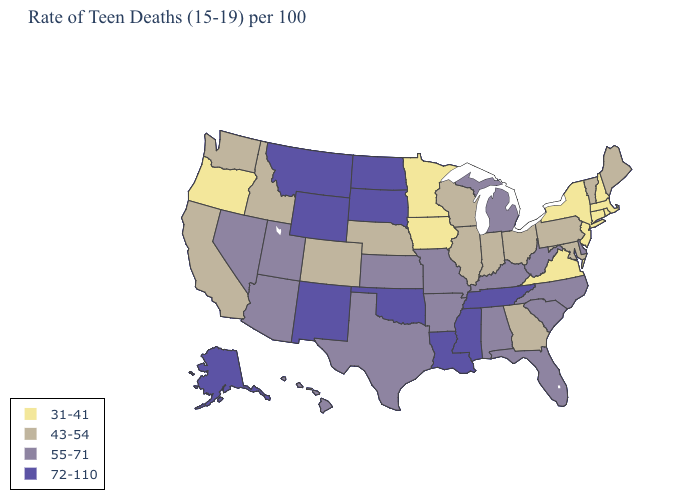What is the value of Alaska?
Keep it brief. 72-110. Which states have the highest value in the USA?
Keep it brief. Alaska, Louisiana, Mississippi, Montana, New Mexico, North Dakota, Oklahoma, South Dakota, Tennessee, Wyoming. Name the states that have a value in the range 31-41?
Answer briefly. Connecticut, Iowa, Massachusetts, Minnesota, New Hampshire, New Jersey, New York, Oregon, Rhode Island, Virginia. Among the states that border West Virginia , does Ohio have the highest value?
Write a very short answer. No. What is the lowest value in states that border Indiana?
Concise answer only. 43-54. What is the value of Missouri?
Keep it brief. 55-71. Name the states that have a value in the range 31-41?
Quick response, please. Connecticut, Iowa, Massachusetts, Minnesota, New Hampshire, New Jersey, New York, Oregon, Rhode Island, Virginia. Name the states that have a value in the range 72-110?
Give a very brief answer. Alaska, Louisiana, Mississippi, Montana, New Mexico, North Dakota, Oklahoma, South Dakota, Tennessee, Wyoming. What is the value of California?
Short answer required. 43-54. Among the states that border Tennessee , which have the lowest value?
Short answer required. Virginia. Does Idaho have the highest value in the USA?
Quick response, please. No. Does Louisiana have the highest value in the USA?
Answer briefly. Yes. What is the lowest value in states that border Rhode Island?
Be succinct. 31-41. What is the value of South Carolina?
Give a very brief answer. 55-71. Does the map have missing data?
Keep it brief. No. 